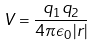Convert formula to latex. <formula><loc_0><loc_0><loc_500><loc_500>V = \frac { q _ { 1 } q _ { 2 } } { 4 \pi \epsilon _ { 0 } | r | }</formula> 